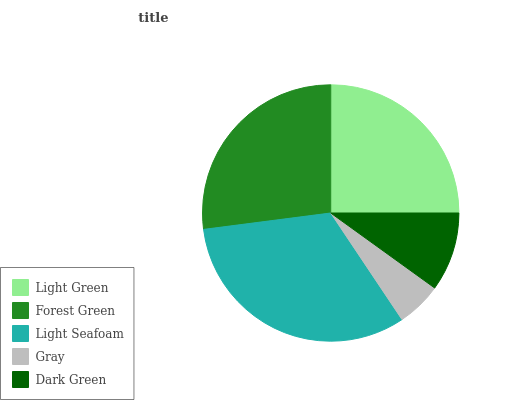Is Gray the minimum?
Answer yes or no. Yes. Is Light Seafoam the maximum?
Answer yes or no. Yes. Is Forest Green the minimum?
Answer yes or no. No. Is Forest Green the maximum?
Answer yes or no. No. Is Forest Green greater than Light Green?
Answer yes or no. Yes. Is Light Green less than Forest Green?
Answer yes or no. Yes. Is Light Green greater than Forest Green?
Answer yes or no. No. Is Forest Green less than Light Green?
Answer yes or no. No. Is Light Green the high median?
Answer yes or no. Yes. Is Light Green the low median?
Answer yes or no. Yes. Is Gray the high median?
Answer yes or no. No. Is Light Seafoam the low median?
Answer yes or no. No. 